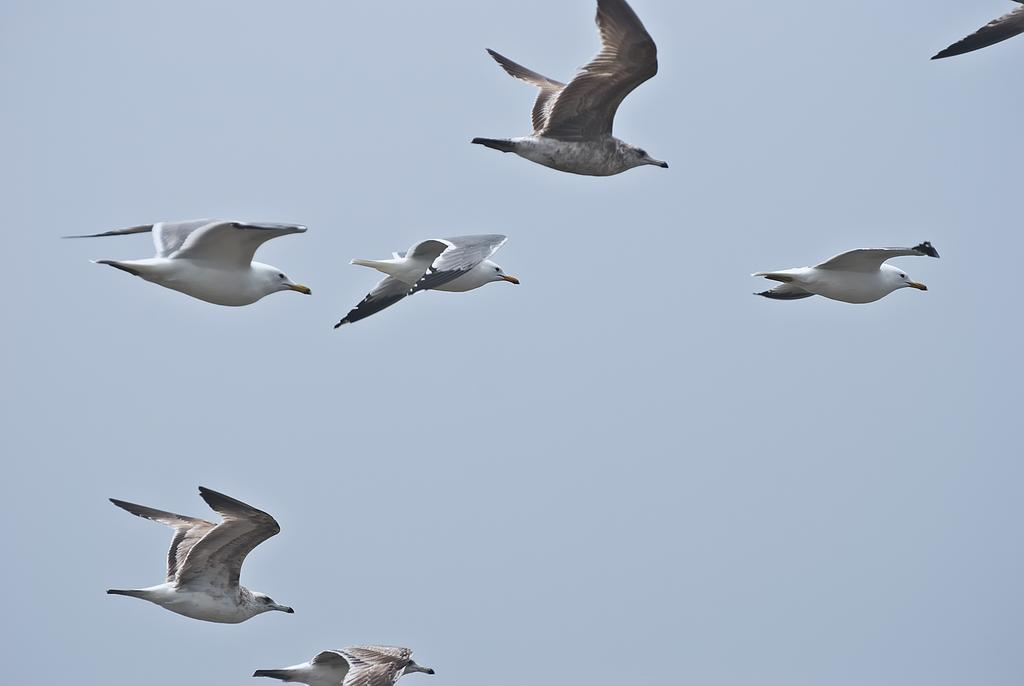Where was the image taken? The image was clicked outside the city. What can be seen in the center of the image? There is a group of birds flying in the air in the center of the image. What is visible in the background of the image? There is a sky visible in the background of the image. Can you see a crown on the head of any bird in the image? There is no crown visible on any bird in the image. How many feet are visible on the birds in the image? Birds' feet are not visible in the image, as they are flying in the air. 